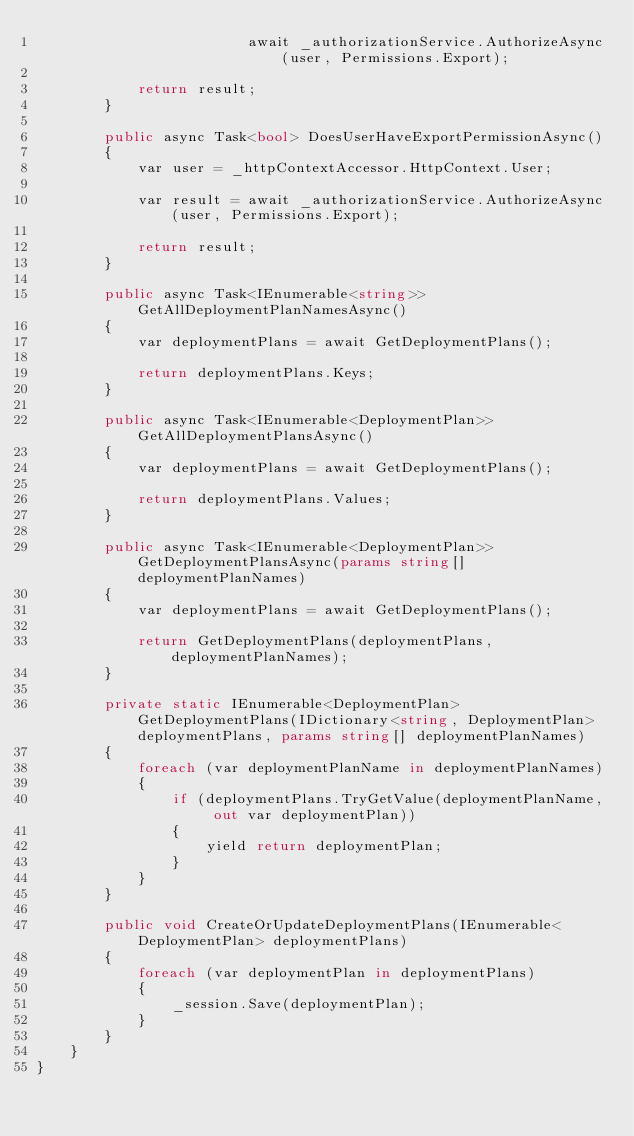<code> <loc_0><loc_0><loc_500><loc_500><_C#_>                         await _authorizationService.AuthorizeAsync(user, Permissions.Export);

            return result;
        }

        public async Task<bool> DoesUserHaveExportPermissionAsync()
        {
            var user = _httpContextAccessor.HttpContext.User;

            var result = await _authorizationService.AuthorizeAsync(user, Permissions.Export);

            return result;
        }

        public async Task<IEnumerable<string>> GetAllDeploymentPlanNamesAsync()
        {
            var deploymentPlans = await GetDeploymentPlans();

            return deploymentPlans.Keys;
        }

        public async Task<IEnumerable<DeploymentPlan>> GetAllDeploymentPlansAsync()
        {
            var deploymentPlans = await GetDeploymentPlans();

            return deploymentPlans.Values;
        }

        public async Task<IEnumerable<DeploymentPlan>> GetDeploymentPlansAsync(params string[] deploymentPlanNames)
        {
            var deploymentPlans = await GetDeploymentPlans();

            return GetDeploymentPlans(deploymentPlans, deploymentPlanNames);
        }

        private static IEnumerable<DeploymentPlan> GetDeploymentPlans(IDictionary<string, DeploymentPlan> deploymentPlans, params string[] deploymentPlanNames)
        {
            foreach (var deploymentPlanName in deploymentPlanNames)
            {
                if (deploymentPlans.TryGetValue(deploymentPlanName, out var deploymentPlan))
                {
                    yield return deploymentPlan;
                }
            }
        }

        public void CreateOrUpdateDeploymentPlans(IEnumerable<DeploymentPlan> deploymentPlans)
        {
            foreach (var deploymentPlan in deploymentPlans)
            {
                _session.Save(deploymentPlan);
            }
        }
    }
}
</code> 